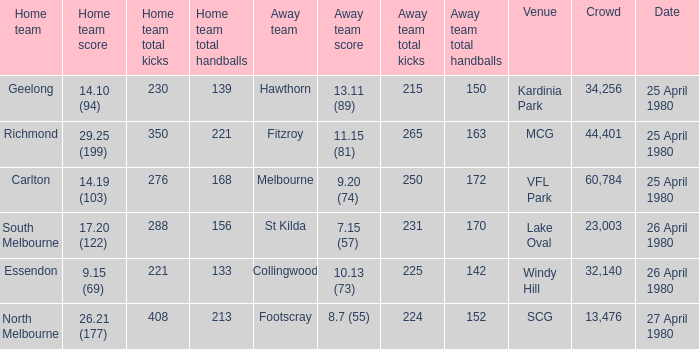What wa the date of the North Melbourne home game? 27 April 1980. 